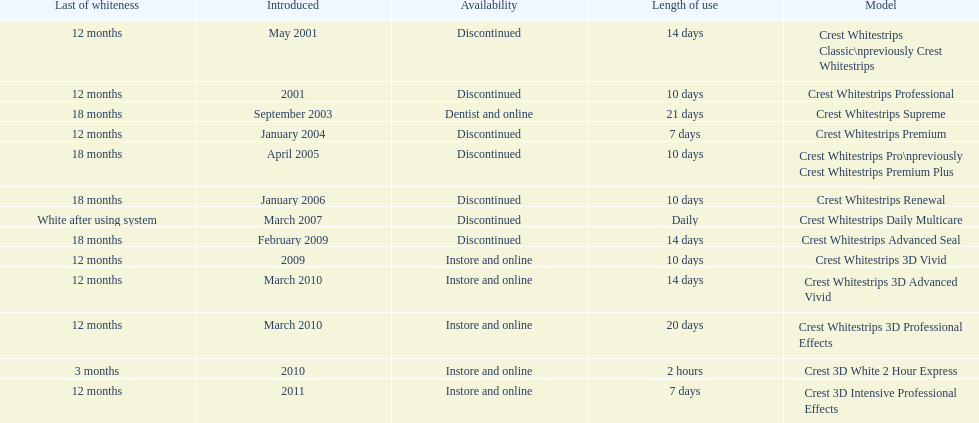How many models require less than a week of use? 2. 